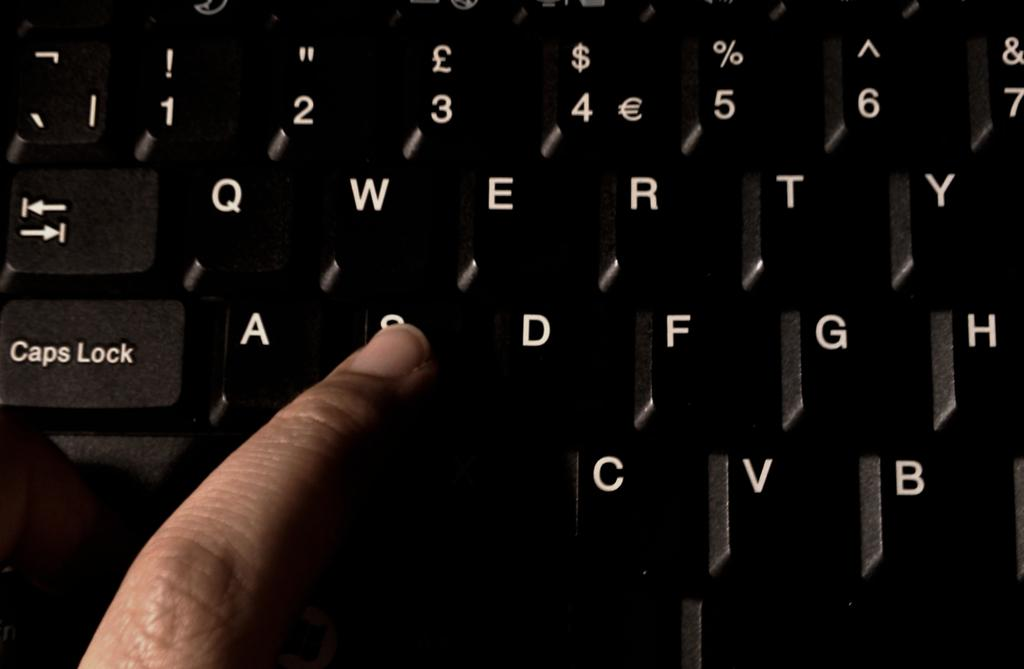<image>
Summarize the visual content of the image. A person is pushing the key between the A and the D on a keyboard. 